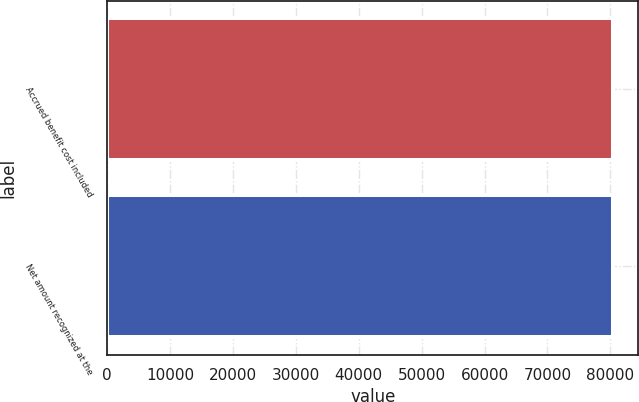<chart> <loc_0><loc_0><loc_500><loc_500><bar_chart><fcel>Accrued benefit cost included<fcel>Net amount recognized at the<nl><fcel>80438<fcel>80438.1<nl></chart> 